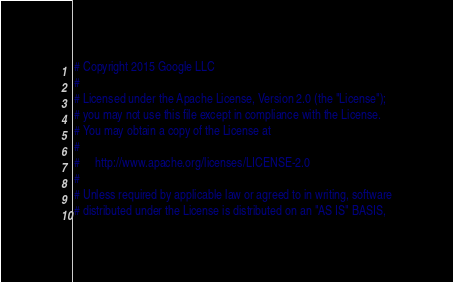<code> <loc_0><loc_0><loc_500><loc_500><_Python_># Copyright 2015 Google LLC
#
# Licensed under the Apache License, Version 2.0 (the "License");
# you may not use this file except in compliance with the License.
# You may obtain a copy of the License at
#
#     http://www.apache.org/licenses/LICENSE-2.0
#
# Unless required by applicable law or agreed to in writing, software
# distributed under the License is distributed on an "AS IS" BASIS,</code> 